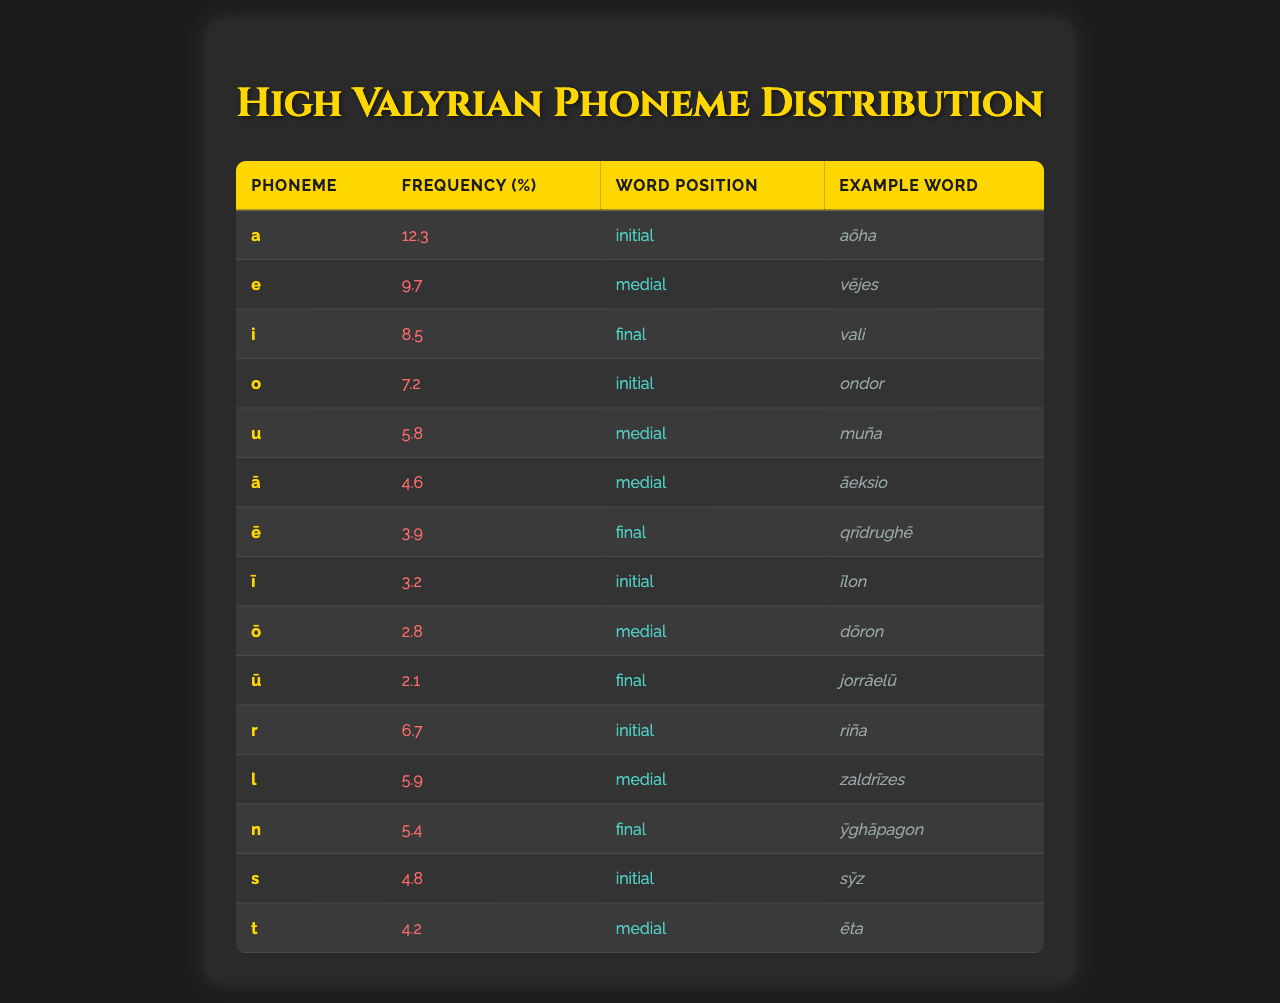What is the most frequently occurring phoneme in High Valyrian? Looking at the "Frequency (%)" column, the highest value is 12.3, which corresponds to the phoneme "a".
Answer: a How many phonemes are listed with a frequency greater than 5%? By counting the "Frequency (%)" values that are above 5, we have the phonemes "a", "e", "i", "o", "u", "r", "l", "n", and "s". That makes a total of 8 phonemes.
Answer: 8 What is the word position of the phoneme "ū"? The table indicates that the word position for "ū" is "final".
Answer: final Which phoneme has the lowest frequency? The lowest frequency listed is 2.1, which corresponds to the phoneme "ū".
Answer: ū Are any vowels represented in both initial and final positions? The phonemes "i" and "u" are found in the "final" position, while "a" and "o" are in "initial", so there are no vowels fitting both categories from the data.
Answer: No What is the average frequency of all phonemes in the table? To calculate, we sum all the frequencies: (12.3 + 9.7 + 8.5 + 7.2 + 5.8 + 4.6 + 3.9 + 3.2 + 2.8 + 2.1 + 6.7 + 5.9 + 5.4 + 4.8 + 4.2) = 73.3. There are 15 phonemes, so the average frequency is 73.3 / 15 ≈ 4.89.
Answer: 4.89 Which phoneme appears most frequently in the initial position? Referring to the "Word Position" and "Frequency (%)" columns, "a" (12.3) and "r" (6.7) are both in the initial position, but "a" has the highest frequency.
Answer: a How many phonemes have a medial word position? The phonemes with a medial position are "e", "u", "ā", "ō", "l", and "t", totaling 6 phonemes.
Answer: 6 What is the total frequency of all the phonemes with a final word position? Adding the frequencies of "i" (8.5), "ē" (3.9), "ū" (2.1), and "n" (5.4), we get 8.5 + 3.9 + 2.1 + 5.4 = 19.9.
Answer: 19.9 Is "s" more frequently occurring than "t"? The frequency of phoneme "s" is 4.8, and for "t" it is 4.2, showing that "s" is indeed more frequent.
Answer: Yes What is the sum of frequencies for phonemes that appear in both initial and medial positions? The phonemes "a" (12.3), "u" (5.8), "r" (6.7), "l" (5.9), and "t" (4.2) fit this requirement. Adding them gives: 12.3 + 5.8 + 6.7 + 5.9 + 4.2 = 35.9.
Answer: 35.9 